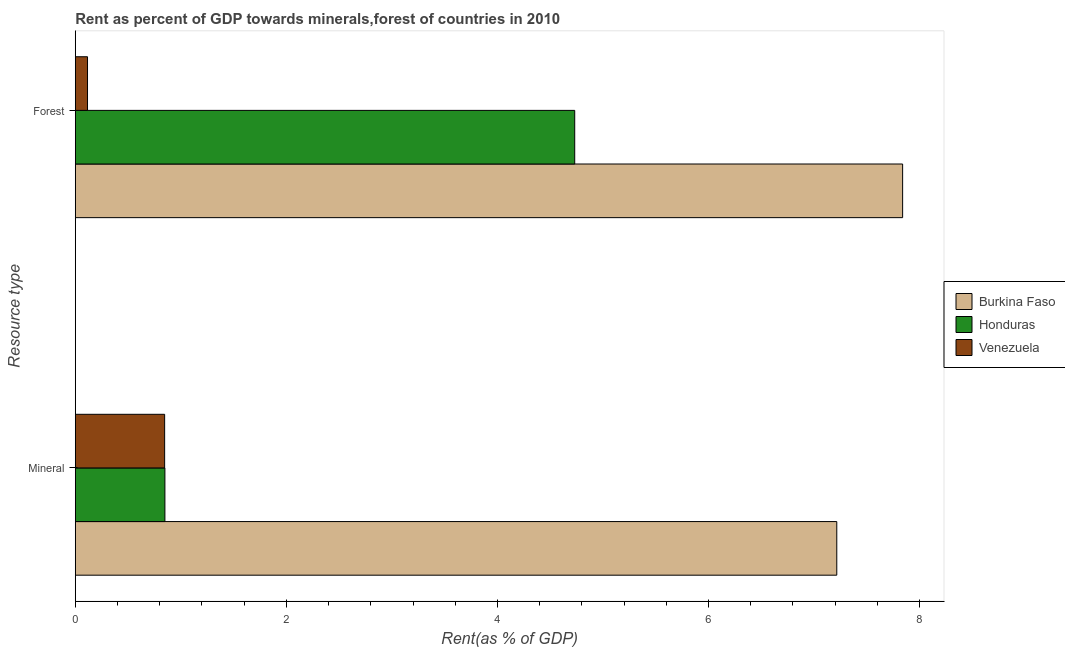How many bars are there on the 1st tick from the bottom?
Your response must be concise. 3. What is the label of the 2nd group of bars from the top?
Ensure brevity in your answer.  Mineral. What is the mineral rent in Venezuela?
Offer a terse response. 0.85. Across all countries, what is the maximum forest rent?
Provide a short and direct response. 7.84. Across all countries, what is the minimum mineral rent?
Provide a short and direct response. 0.85. In which country was the forest rent maximum?
Offer a terse response. Burkina Faso. In which country was the mineral rent minimum?
Provide a short and direct response. Venezuela. What is the total mineral rent in the graph?
Your response must be concise. 8.91. What is the difference between the mineral rent in Venezuela and that in Honduras?
Your answer should be compact. -0. What is the difference between the forest rent in Burkina Faso and the mineral rent in Venezuela?
Your answer should be compact. 6.99. What is the average mineral rent per country?
Your answer should be very brief. 2.97. What is the difference between the mineral rent and forest rent in Venezuela?
Keep it short and to the point. 0.73. In how many countries, is the mineral rent greater than 6.8 %?
Your response must be concise. 1. What is the ratio of the forest rent in Burkina Faso to that in Venezuela?
Your answer should be very brief. 67.76. In how many countries, is the forest rent greater than the average forest rent taken over all countries?
Offer a terse response. 2. What does the 3rd bar from the top in Mineral represents?
Keep it short and to the point. Burkina Faso. What does the 2nd bar from the bottom in Mineral represents?
Offer a very short reply. Honduras. Are all the bars in the graph horizontal?
Keep it short and to the point. Yes. How many countries are there in the graph?
Your answer should be very brief. 3. Does the graph contain any zero values?
Ensure brevity in your answer.  No. Does the graph contain grids?
Offer a very short reply. No. Where does the legend appear in the graph?
Offer a very short reply. Center right. What is the title of the graph?
Offer a very short reply. Rent as percent of GDP towards minerals,forest of countries in 2010. What is the label or title of the X-axis?
Make the answer very short. Rent(as % of GDP). What is the label or title of the Y-axis?
Ensure brevity in your answer.  Resource type. What is the Rent(as % of GDP) in Burkina Faso in Mineral?
Your answer should be very brief. 7.22. What is the Rent(as % of GDP) of Honduras in Mineral?
Give a very brief answer. 0.85. What is the Rent(as % of GDP) of Venezuela in Mineral?
Your response must be concise. 0.85. What is the Rent(as % of GDP) in Burkina Faso in Forest?
Provide a short and direct response. 7.84. What is the Rent(as % of GDP) in Honduras in Forest?
Ensure brevity in your answer.  4.73. What is the Rent(as % of GDP) of Venezuela in Forest?
Give a very brief answer. 0.12. Across all Resource type, what is the maximum Rent(as % of GDP) in Burkina Faso?
Your answer should be compact. 7.84. Across all Resource type, what is the maximum Rent(as % of GDP) in Honduras?
Provide a short and direct response. 4.73. Across all Resource type, what is the maximum Rent(as % of GDP) of Venezuela?
Ensure brevity in your answer.  0.85. Across all Resource type, what is the minimum Rent(as % of GDP) in Burkina Faso?
Make the answer very short. 7.22. Across all Resource type, what is the minimum Rent(as % of GDP) in Honduras?
Ensure brevity in your answer.  0.85. Across all Resource type, what is the minimum Rent(as % of GDP) of Venezuela?
Your answer should be compact. 0.12. What is the total Rent(as % of GDP) in Burkina Faso in the graph?
Your response must be concise. 15.05. What is the total Rent(as % of GDP) of Honduras in the graph?
Offer a very short reply. 5.58. What is the total Rent(as % of GDP) of Venezuela in the graph?
Provide a short and direct response. 0.96. What is the difference between the Rent(as % of GDP) in Burkina Faso in Mineral and that in Forest?
Provide a succinct answer. -0.62. What is the difference between the Rent(as % of GDP) of Honduras in Mineral and that in Forest?
Provide a succinct answer. -3.88. What is the difference between the Rent(as % of GDP) in Venezuela in Mineral and that in Forest?
Provide a short and direct response. 0.73. What is the difference between the Rent(as % of GDP) in Burkina Faso in Mineral and the Rent(as % of GDP) in Honduras in Forest?
Offer a terse response. 2.48. What is the difference between the Rent(as % of GDP) in Burkina Faso in Mineral and the Rent(as % of GDP) in Venezuela in Forest?
Ensure brevity in your answer.  7.1. What is the difference between the Rent(as % of GDP) in Honduras in Mineral and the Rent(as % of GDP) in Venezuela in Forest?
Ensure brevity in your answer.  0.73. What is the average Rent(as % of GDP) in Burkina Faso per Resource type?
Provide a short and direct response. 7.53. What is the average Rent(as % of GDP) in Honduras per Resource type?
Your answer should be compact. 2.79. What is the average Rent(as % of GDP) of Venezuela per Resource type?
Your answer should be very brief. 0.48. What is the difference between the Rent(as % of GDP) in Burkina Faso and Rent(as % of GDP) in Honduras in Mineral?
Provide a succinct answer. 6.37. What is the difference between the Rent(as % of GDP) in Burkina Faso and Rent(as % of GDP) in Venezuela in Mineral?
Make the answer very short. 6.37. What is the difference between the Rent(as % of GDP) in Honduras and Rent(as % of GDP) in Venezuela in Mineral?
Offer a terse response. 0. What is the difference between the Rent(as % of GDP) in Burkina Faso and Rent(as % of GDP) in Honduras in Forest?
Your answer should be very brief. 3.11. What is the difference between the Rent(as % of GDP) of Burkina Faso and Rent(as % of GDP) of Venezuela in Forest?
Your answer should be compact. 7.72. What is the difference between the Rent(as % of GDP) in Honduras and Rent(as % of GDP) in Venezuela in Forest?
Ensure brevity in your answer.  4.62. What is the ratio of the Rent(as % of GDP) of Burkina Faso in Mineral to that in Forest?
Give a very brief answer. 0.92. What is the ratio of the Rent(as % of GDP) in Honduras in Mineral to that in Forest?
Your answer should be compact. 0.18. What is the ratio of the Rent(as % of GDP) of Venezuela in Mineral to that in Forest?
Provide a succinct answer. 7.32. What is the difference between the highest and the second highest Rent(as % of GDP) in Burkina Faso?
Your response must be concise. 0.62. What is the difference between the highest and the second highest Rent(as % of GDP) in Honduras?
Make the answer very short. 3.88. What is the difference between the highest and the second highest Rent(as % of GDP) in Venezuela?
Your response must be concise. 0.73. What is the difference between the highest and the lowest Rent(as % of GDP) of Burkina Faso?
Offer a very short reply. 0.62. What is the difference between the highest and the lowest Rent(as % of GDP) in Honduras?
Offer a very short reply. 3.88. What is the difference between the highest and the lowest Rent(as % of GDP) in Venezuela?
Ensure brevity in your answer.  0.73. 